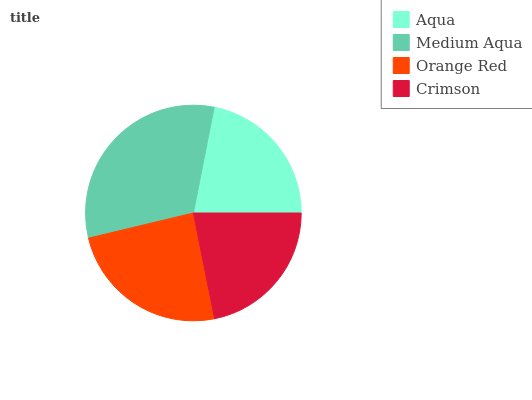Is Crimson the minimum?
Answer yes or no. Yes. Is Medium Aqua the maximum?
Answer yes or no. Yes. Is Orange Red the minimum?
Answer yes or no. No. Is Orange Red the maximum?
Answer yes or no. No. Is Medium Aqua greater than Orange Red?
Answer yes or no. Yes. Is Orange Red less than Medium Aqua?
Answer yes or no. Yes. Is Orange Red greater than Medium Aqua?
Answer yes or no. No. Is Medium Aqua less than Orange Red?
Answer yes or no. No. Is Orange Red the high median?
Answer yes or no. Yes. Is Aqua the low median?
Answer yes or no. Yes. Is Medium Aqua the high median?
Answer yes or no. No. Is Orange Red the low median?
Answer yes or no. No. 